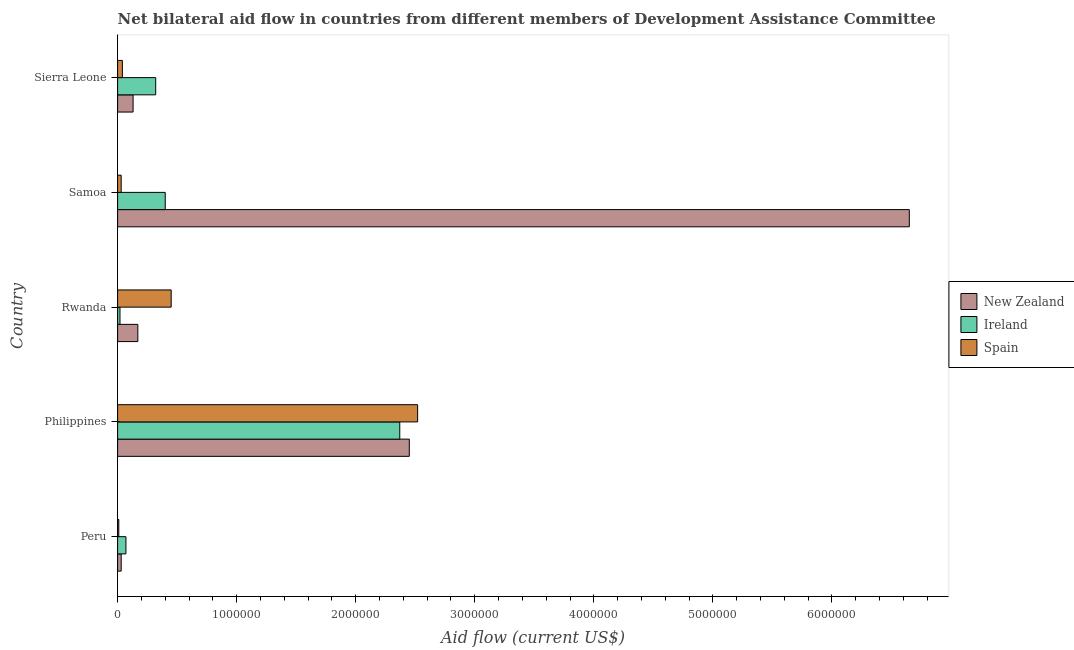How many different coloured bars are there?
Your response must be concise. 3. How many groups of bars are there?
Your answer should be compact. 5. Are the number of bars per tick equal to the number of legend labels?
Offer a very short reply. Yes. Are the number of bars on each tick of the Y-axis equal?
Make the answer very short. Yes. How many bars are there on the 3rd tick from the top?
Keep it short and to the point. 3. How many bars are there on the 2nd tick from the bottom?
Your response must be concise. 3. What is the label of the 3rd group of bars from the top?
Keep it short and to the point. Rwanda. What is the amount of aid provided by spain in Rwanda?
Your response must be concise. 4.50e+05. Across all countries, what is the maximum amount of aid provided by new zealand?
Ensure brevity in your answer.  6.65e+06. Across all countries, what is the minimum amount of aid provided by spain?
Keep it short and to the point. 10000. What is the total amount of aid provided by spain in the graph?
Offer a very short reply. 3.05e+06. What is the difference between the amount of aid provided by spain in Samoa and that in Sierra Leone?
Your answer should be compact. -10000. What is the difference between the amount of aid provided by new zealand in Philippines and the amount of aid provided by ireland in Peru?
Your answer should be very brief. 2.38e+06. What is the average amount of aid provided by spain per country?
Provide a short and direct response. 6.10e+05. What is the difference between the amount of aid provided by ireland and amount of aid provided by new zealand in Rwanda?
Offer a terse response. -1.50e+05. What is the ratio of the amount of aid provided by new zealand in Rwanda to that in Samoa?
Keep it short and to the point. 0.03. Is the amount of aid provided by ireland in Rwanda less than that in Samoa?
Make the answer very short. Yes. What is the difference between the highest and the second highest amount of aid provided by new zealand?
Your answer should be very brief. 4.20e+06. What is the difference between the highest and the lowest amount of aid provided by new zealand?
Your response must be concise. 6.62e+06. In how many countries, is the amount of aid provided by spain greater than the average amount of aid provided by spain taken over all countries?
Ensure brevity in your answer.  1. Is the sum of the amount of aid provided by new zealand in Philippines and Sierra Leone greater than the maximum amount of aid provided by spain across all countries?
Keep it short and to the point. Yes. What does the 1st bar from the bottom in Sierra Leone represents?
Keep it short and to the point. New Zealand. How many bars are there?
Provide a succinct answer. 15. How many countries are there in the graph?
Provide a short and direct response. 5. What is the difference between two consecutive major ticks on the X-axis?
Offer a very short reply. 1.00e+06. Are the values on the major ticks of X-axis written in scientific E-notation?
Your response must be concise. No. How are the legend labels stacked?
Provide a short and direct response. Vertical. What is the title of the graph?
Provide a short and direct response. Net bilateral aid flow in countries from different members of Development Assistance Committee. What is the label or title of the Y-axis?
Provide a short and direct response. Country. What is the Aid flow (current US$) of Ireland in Peru?
Make the answer very short. 7.00e+04. What is the Aid flow (current US$) of New Zealand in Philippines?
Your response must be concise. 2.45e+06. What is the Aid flow (current US$) in Ireland in Philippines?
Make the answer very short. 2.37e+06. What is the Aid flow (current US$) in Spain in Philippines?
Offer a terse response. 2.52e+06. What is the Aid flow (current US$) in New Zealand in Rwanda?
Ensure brevity in your answer.  1.70e+05. What is the Aid flow (current US$) in Spain in Rwanda?
Offer a very short reply. 4.50e+05. What is the Aid flow (current US$) in New Zealand in Samoa?
Ensure brevity in your answer.  6.65e+06. What is the Aid flow (current US$) of Ireland in Sierra Leone?
Provide a short and direct response. 3.20e+05. Across all countries, what is the maximum Aid flow (current US$) of New Zealand?
Provide a short and direct response. 6.65e+06. Across all countries, what is the maximum Aid flow (current US$) of Ireland?
Provide a succinct answer. 2.37e+06. Across all countries, what is the maximum Aid flow (current US$) in Spain?
Your response must be concise. 2.52e+06. Across all countries, what is the minimum Aid flow (current US$) in Spain?
Make the answer very short. 10000. What is the total Aid flow (current US$) in New Zealand in the graph?
Keep it short and to the point. 9.43e+06. What is the total Aid flow (current US$) of Ireland in the graph?
Ensure brevity in your answer.  3.18e+06. What is the total Aid flow (current US$) of Spain in the graph?
Your response must be concise. 3.05e+06. What is the difference between the Aid flow (current US$) of New Zealand in Peru and that in Philippines?
Ensure brevity in your answer.  -2.42e+06. What is the difference between the Aid flow (current US$) of Ireland in Peru and that in Philippines?
Offer a very short reply. -2.30e+06. What is the difference between the Aid flow (current US$) of Spain in Peru and that in Philippines?
Your answer should be very brief. -2.51e+06. What is the difference between the Aid flow (current US$) in New Zealand in Peru and that in Rwanda?
Your answer should be very brief. -1.40e+05. What is the difference between the Aid flow (current US$) of Spain in Peru and that in Rwanda?
Your answer should be very brief. -4.40e+05. What is the difference between the Aid flow (current US$) of New Zealand in Peru and that in Samoa?
Offer a very short reply. -6.62e+06. What is the difference between the Aid flow (current US$) of Ireland in Peru and that in Samoa?
Give a very brief answer. -3.30e+05. What is the difference between the Aid flow (current US$) of New Zealand in Peru and that in Sierra Leone?
Offer a terse response. -1.00e+05. What is the difference between the Aid flow (current US$) of Ireland in Peru and that in Sierra Leone?
Make the answer very short. -2.50e+05. What is the difference between the Aid flow (current US$) of New Zealand in Philippines and that in Rwanda?
Give a very brief answer. 2.28e+06. What is the difference between the Aid flow (current US$) in Ireland in Philippines and that in Rwanda?
Offer a terse response. 2.35e+06. What is the difference between the Aid flow (current US$) in Spain in Philippines and that in Rwanda?
Your response must be concise. 2.07e+06. What is the difference between the Aid flow (current US$) of New Zealand in Philippines and that in Samoa?
Provide a succinct answer. -4.20e+06. What is the difference between the Aid flow (current US$) in Ireland in Philippines and that in Samoa?
Give a very brief answer. 1.97e+06. What is the difference between the Aid flow (current US$) of Spain in Philippines and that in Samoa?
Your response must be concise. 2.49e+06. What is the difference between the Aid flow (current US$) in New Zealand in Philippines and that in Sierra Leone?
Keep it short and to the point. 2.32e+06. What is the difference between the Aid flow (current US$) of Ireland in Philippines and that in Sierra Leone?
Provide a succinct answer. 2.05e+06. What is the difference between the Aid flow (current US$) of Spain in Philippines and that in Sierra Leone?
Your response must be concise. 2.48e+06. What is the difference between the Aid flow (current US$) in New Zealand in Rwanda and that in Samoa?
Offer a very short reply. -6.48e+06. What is the difference between the Aid flow (current US$) in Ireland in Rwanda and that in Samoa?
Ensure brevity in your answer.  -3.80e+05. What is the difference between the Aid flow (current US$) in New Zealand in Rwanda and that in Sierra Leone?
Your answer should be very brief. 4.00e+04. What is the difference between the Aid flow (current US$) of New Zealand in Samoa and that in Sierra Leone?
Provide a short and direct response. 6.52e+06. What is the difference between the Aid flow (current US$) in Ireland in Samoa and that in Sierra Leone?
Keep it short and to the point. 8.00e+04. What is the difference between the Aid flow (current US$) in Spain in Samoa and that in Sierra Leone?
Offer a very short reply. -10000. What is the difference between the Aid flow (current US$) of New Zealand in Peru and the Aid flow (current US$) of Ireland in Philippines?
Give a very brief answer. -2.34e+06. What is the difference between the Aid flow (current US$) of New Zealand in Peru and the Aid flow (current US$) of Spain in Philippines?
Offer a terse response. -2.49e+06. What is the difference between the Aid flow (current US$) in Ireland in Peru and the Aid flow (current US$) in Spain in Philippines?
Offer a very short reply. -2.45e+06. What is the difference between the Aid flow (current US$) in New Zealand in Peru and the Aid flow (current US$) in Spain in Rwanda?
Your answer should be very brief. -4.20e+05. What is the difference between the Aid flow (current US$) in Ireland in Peru and the Aid flow (current US$) in Spain in Rwanda?
Keep it short and to the point. -3.80e+05. What is the difference between the Aid flow (current US$) of New Zealand in Peru and the Aid flow (current US$) of Ireland in Samoa?
Give a very brief answer. -3.70e+05. What is the difference between the Aid flow (current US$) in New Zealand in Peru and the Aid flow (current US$) in Ireland in Sierra Leone?
Your answer should be very brief. -2.90e+05. What is the difference between the Aid flow (current US$) of Ireland in Peru and the Aid flow (current US$) of Spain in Sierra Leone?
Provide a short and direct response. 3.00e+04. What is the difference between the Aid flow (current US$) of New Zealand in Philippines and the Aid flow (current US$) of Ireland in Rwanda?
Make the answer very short. 2.43e+06. What is the difference between the Aid flow (current US$) of New Zealand in Philippines and the Aid flow (current US$) of Spain in Rwanda?
Provide a short and direct response. 2.00e+06. What is the difference between the Aid flow (current US$) of Ireland in Philippines and the Aid flow (current US$) of Spain in Rwanda?
Provide a succinct answer. 1.92e+06. What is the difference between the Aid flow (current US$) of New Zealand in Philippines and the Aid flow (current US$) of Ireland in Samoa?
Provide a succinct answer. 2.05e+06. What is the difference between the Aid flow (current US$) of New Zealand in Philippines and the Aid flow (current US$) of Spain in Samoa?
Your answer should be compact. 2.42e+06. What is the difference between the Aid flow (current US$) in Ireland in Philippines and the Aid flow (current US$) in Spain in Samoa?
Offer a terse response. 2.34e+06. What is the difference between the Aid flow (current US$) of New Zealand in Philippines and the Aid flow (current US$) of Ireland in Sierra Leone?
Provide a succinct answer. 2.13e+06. What is the difference between the Aid flow (current US$) in New Zealand in Philippines and the Aid flow (current US$) in Spain in Sierra Leone?
Your answer should be very brief. 2.41e+06. What is the difference between the Aid flow (current US$) in Ireland in Philippines and the Aid flow (current US$) in Spain in Sierra Leone?
Your answer should be very brief. 2.33e+06. What is the difference between the Aid flow (current US$) of New Zealand in Rwanda and the Aid flow (current US$) of Ireland in Samoa?
Give a very brief answer. -2.30e+05. What is the difference between the Aid flow (current US$) of New Zealand in Rwanda and the Aid flow (current US$) of Spain in Samoa?
Give a very brief answer. 1.40e+05. What is the difference between the Aid flow (current US$) of New Zealand in Rwanda and the Aid flow (current US$) of Ireland in Sierra Leone?
Your answer should be compact. -1.50e+05. What is the difference between the Aid flow (current US$) of Ireland in Rwanda and the Aid flow (current US$) of Spain in Sierra Leone?
Ensure brevity in your answer.  -2.00e+04. What is the difference between the Aid flow (current US$) of New Zealand in Samoa and the Aid flow (current US$) of Ireland in Sierra Leone?
Offer a terse response. 6.33e+06. What is the difference between the Aid flow (current US$) of New Zealand in Samoa and the Aid flow (current US$) of Spain in Sierra Leone?
Offer a terse response. 6.61e+06. What is the average Aid flow (current US$) of New Zealand per country?
Give a very brief answer. 1.89e+06. What is the average Aid flow (current US$) of Ireland per country?
Offer a terse response. 6.36e+05. What is the average Aid flow (current US$) of Spain per country?
Provide a succinct answer. 6.10e+05. What is the difference between the Aid flow (current US$) of New Zealand and Aid flow (current US$) of Ireland in Peru?
Your answer should be compact. -4.00e+04. What is the difference between the Aid flow (current US$) in New Zealand and Aid flow (current US$) in Spain in Peru?
Keep it short and to the point. 2.00e+04. What is the difference between the Aid flow (current US$) of New Zealand and Aid flow (current US$) of Ireland in Philippines?
Keep it short and to the point. 8.00e+04. What is the difference between the Aid flow (current US$) in New Zealand and Aid flow (current US$) in Spain in Rwanda?
Provide a succinct answer. -2.80e+05. What is the difference between the Aid flow (current US$) of Ireland and Aid flow (current US$) of Spain in Rwanda?
Your answer should be very brief. -4.30e+05. What is the difference between the Aid flow (current US$) of New Zealand and Aid flow (current US$) of Ireland in Samoa?
Keep it short and to the point. 6.25e+06. What is the difference between the Aid flow (current US$) in New Zealand and Aid flow (current US$) in Spain in Samoa?
Give a very brief answer. 6.62e+06. What is the difference between the Aid flow (current US$) in New Zealand and Aid flow (current US$) in Spain in Sierra Leone?
Ensure brevity in your answer.  9.00e+04. What is the difference between the Aid flow (current US$) in Ireland and Aid flow (current US$) in Spain in Sierra Leone?
Provide a succinct answer. 2.80e+05. What is the ratio of the Aid flow (current US$) in New Zealand in Peru to that in Philippines?
Give a very brief answer. 0.01. What is the ratio of the Aid flow (current US$) in Ireland in Peru to that in Philippines?
Offer a very short reply. 0.03. What is the ratio of the Aid flow (current US$) of Spain in Peru to that in Philippines?
Your response must be concise. 0. What is the ratio of the Aid flow (current US$) in New Zealand in Peru to that in Rwanda?
Provide a succinct answer. 0.18. What is the ratio of the Aid flow (current US$) of Ireland in Peru to that in Rwanda?
Make the answer very short. 3.5. What is the ratio of the Aid flow (current US$) in Spain in Peru to that in Rwanda?
Your response must be concise. 0.02. What is the ratio of the Aid flow (current US$) in New Zealand in Peru to that in Samoa?
Give a very brief answer. 0. What is the ratio of the Aid flow (current US$) in Ireland in Peru to that in Samoa?
Your response must be concise. 0.17. What is the ratio of the Aid flow (current US$) in Spain in Peru to that in Samoa?
Provide a short and direct response. 0.33. What is the ratio of the Aid flow (current US$) of New Zealand in Peru to that in Sierra Leone?
Offer a very short reply. 0.23. What is the ratio of the Aid flow (current US$) of Ireland in Peru to that in Sierra Leone?
Offer a terse response. 0.22. What is the ratio of the Aid flow (current US$) of Spain in Peru to that in Sierra Leone?
Give a very brief answer. 0.25. What is the ratio of the Aid flow (current US$) in New Zealand in Philippines to that in Rwanda?
Offer a very short reply. 14.41. What is the ratio of the Aid flow (current US$) in Ireland in Philippines to that in Rwanda?
Make the answer very short. 118.5. What is the ratio of the Aid flow (current US$) of New Zealand in Philippines to that in Samoa?
Make the answer very short. 0.37. What is the ratio of the Aid flow (current US$) in Ireland in Philippines to that in Samoa?
Make the answer very short. 5.92. What is the ratio of the Aid flow (current US$) of New Zealand in Philippines to that in Sierra Leone?
Your answer should be compact. 18.85. What is the ratio of the Aid flow (current US$) of Ireland in Philippines to that in Sierra Leone?
Ensure brevity in your answer.  7.41. What is the ratio of the Aid flow (current US$) in New Zealand in Rwanda to that in Samoa?
Provide a succinct answer. 0.03. What is the ratio of the Aid flow (current US$) of Ireland in Rwanda to that in Samoa?
Your answer should be compact. 0.05. What is the ratio of the Aid flow (current US$) in Spain in Rwanda to that in Samoa?
Make the answer very short. 15. What is the ratio of the Aid flow (current US$) in New Zealand in Rwanda to that in Sierra Leone?
Provide a succinct answer. 1.31. What is the ratio of the Aid flow (current US$) in Ireland in Rwanda to that in Sierra Leone?
Provide a short and direct response. 0.06. What is the ratio of the Aid flow (current US$) in Spain in Rwanda to that in Sierra Leone?
Give a very brief answer. 11.25. What is the ratio of the Aid flow (current US$) of New Zealand in Samoa to that in Sierra Leone?
Provide a succinct answer. 51.15. What is the ratio of the Aid flow (current US$) of Ireland in Samoa to that in Sierra Leone?
Ensure brevity in your answer.  1.25. What is the ratio of the Aid flow (current US$) of Spain in Samoa to that in Sierra Leone?
Give a very brief answer. 0.75. What is the difference between the highest and the second highest Aid flow (current US$) of New Zealand?
Give a very brief answer. 4.20e+06. What is the difference between the highest and the second highest Aid flow (current US$) of Ireland?
Make the answer very short. 1.97e+06. What is the difference between the highest and the second highest Aid flow (current US$) in Spain?
Your answer should be compact. 2.07e+06. What is the difference between the highest and the lowest Aid flow (current US$) in New Zealand?
Your answer should be very brief. 6.62e+06. What is the difference between the highest and the lowest Aid flow (current US$) of Ireland?
Keep it short and to the point. 2.35e+06. What is the difference between the highest and the lowest Aid flow (current US$) in Spain?
Ensure brevity in your answer.  2.51e+06. 